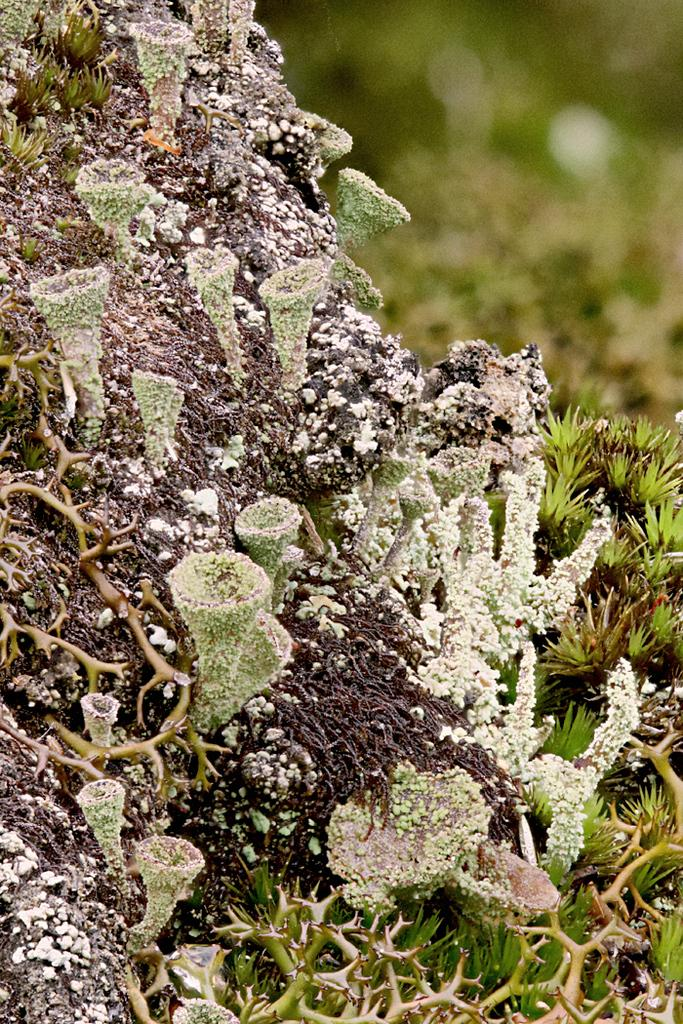What type of vegetation is present in the image? There are creepers, grass, and plants in the image. Can you describe the ground in the image? The ground is covered with grass. What time of day might the image have been taken? The image might have been taken during the day, as there is sufficient light to see the vegetation clearly. Can you see a tiger hiding among the plants in the image? No, there is no tiger present in the image. 